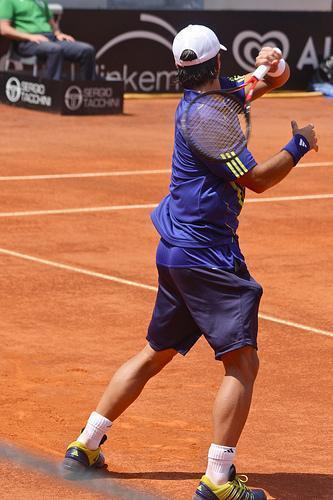How many people are in the background?
Give a very brief answer. 1. 